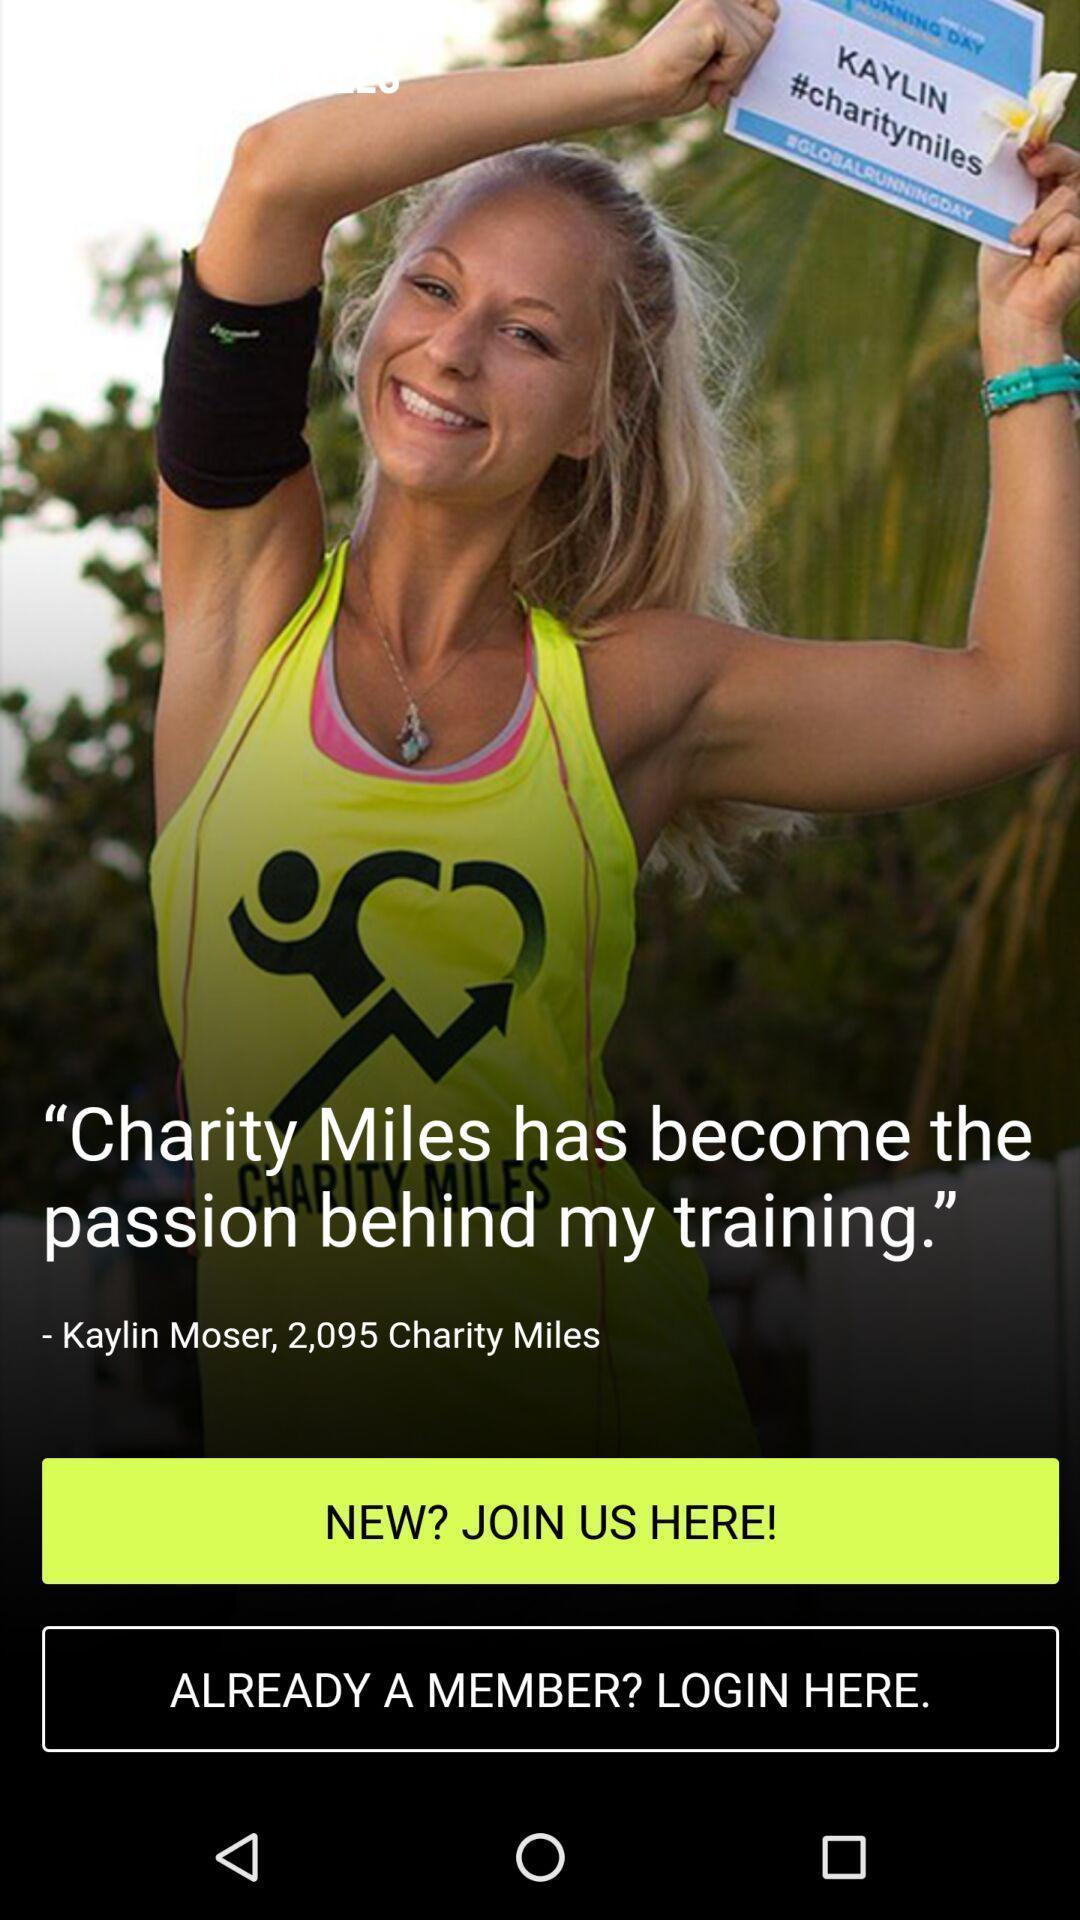Provide a detailed account of this screenshot. Welcome page in a charity app. 